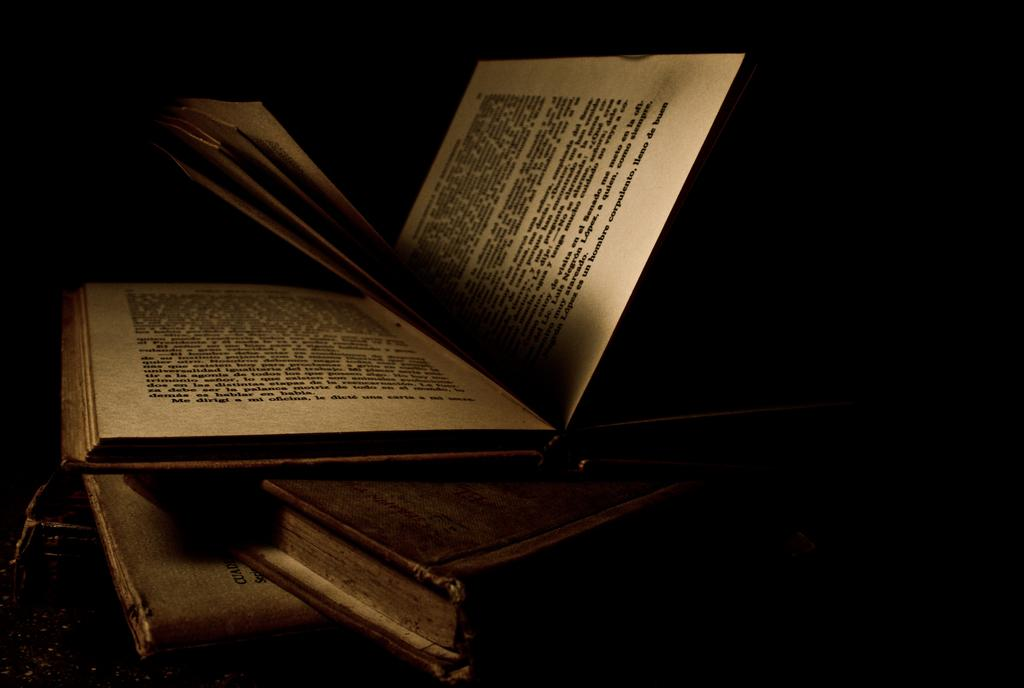Provide a one-sentence caption for the provided image. A book is open and says corpulento on the last line of the page. 